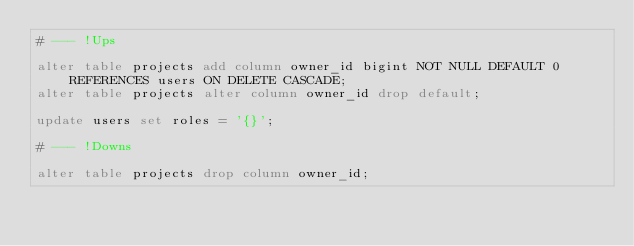<code> <loc_0><loc_0><loc_500><loc_500><_SQL_># --- !Ups

alter table projects add column owner_id bigint NOT NULL DEFAULT 0 REFERENCES users ON DELETE CASCADE;
alter table projects alter column owner_id drop default;

update users set roles = '{}';

# --- !Downs

alter table projects drop column owner_id;
</code> 